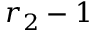Convert formula to latex. <formula><loc_0><loc_0><loc_500><loc_500>r _ { 2 } - 1</formula> 